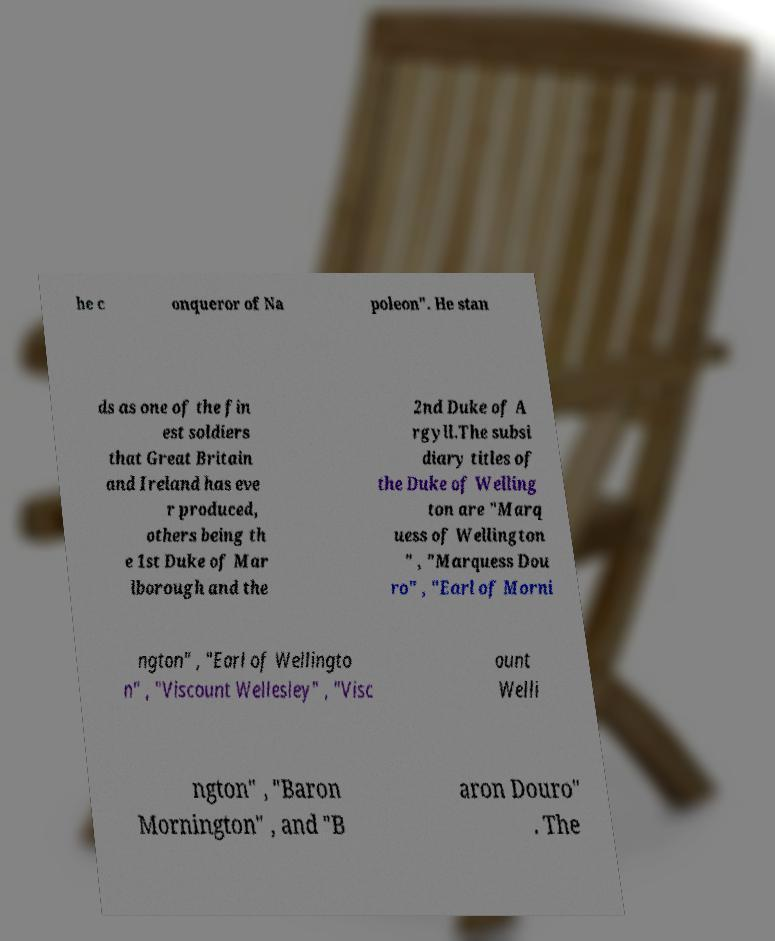Please identify and transcribe the text found in this image. he c onqueror of Na poleon". He stan ds as one of the fin est soldiers that Great Britain and Ireland has eve r produced, others being th e 1st Duke of Mar lborough and the 2nd Duke of A rgyll.The subsi diary titles of the Duke of Welling ton are "Marq uess of Wellington " , "Marquess Dou ro" , "Earl of Morni ngton" , "Earl of Wellingto n" , "Viscount Wellesley" , "Visc ount Welli ngton" , "Baron Mornington" , and "B aron Douro" . The 